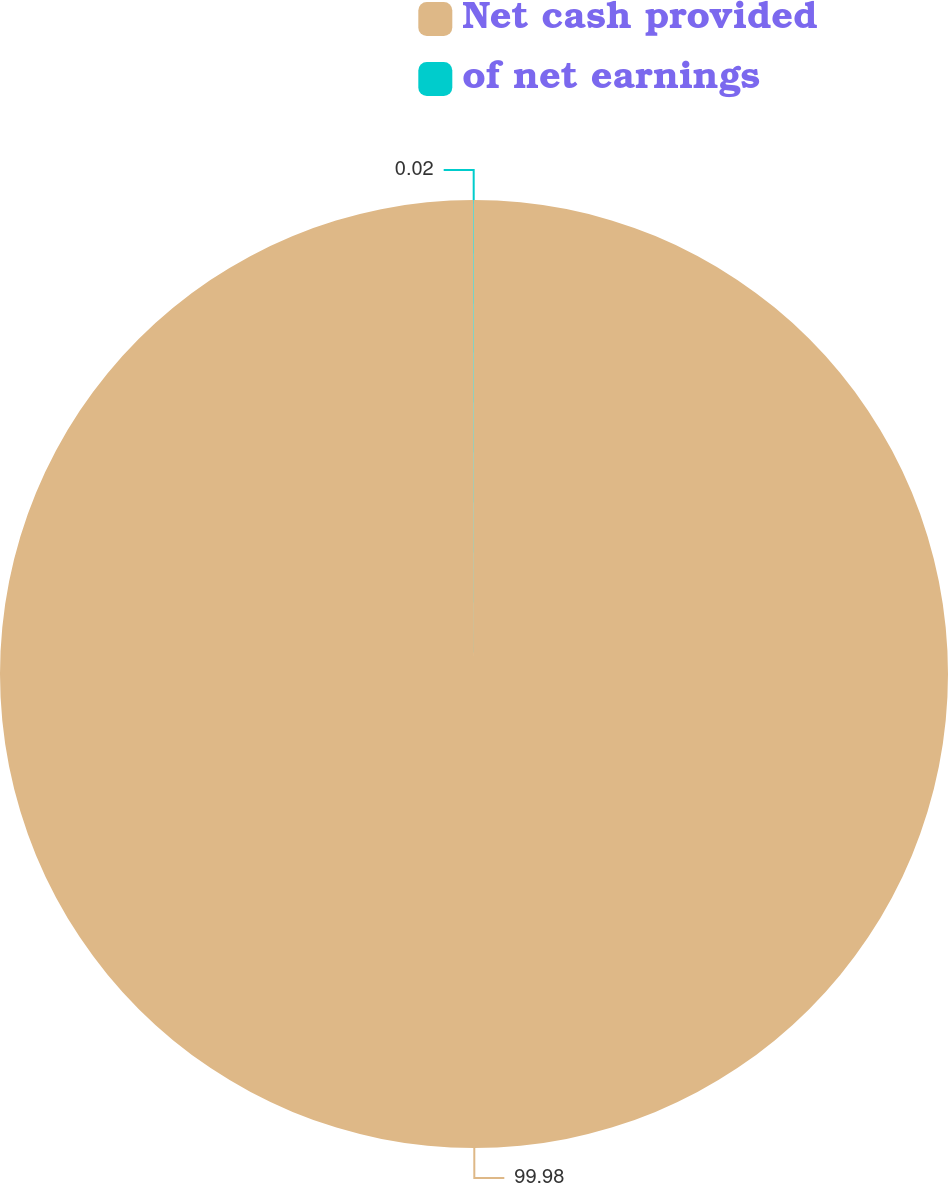<chart> <loc_0><loc_0><loc_500><loc_500><pie_chart><fcel>Net cash provided<fcel>of net earnings<nl><fcel>99.98%<fcel>0.02%<nl></chart> 